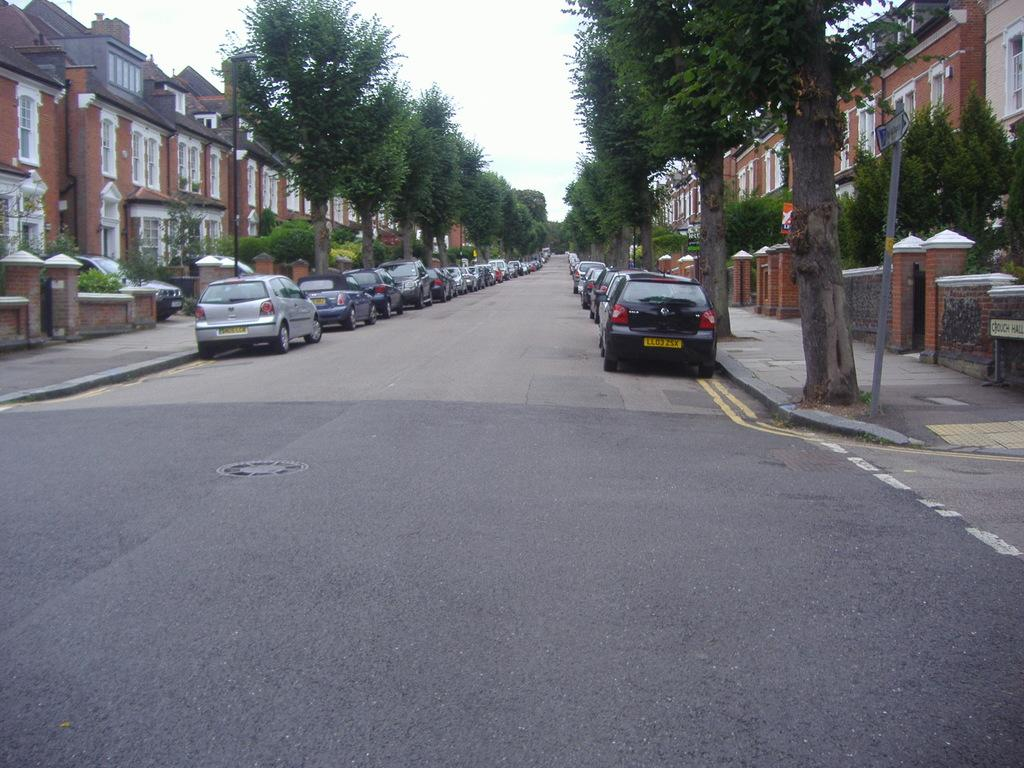What type of natural elements can be seen in the image? There are trees in the image. What type of man-made structures are visible in the image? There are buildings in the image. What are the tall, thin objects in the image? There are poles in the image. What type of vehicles can be seen in the image? There are cars in the image. How would you describe the setting of the image? The image appears to be a street view. Is there a bridge visible in the image? No, there is no bridge present in the image. Can you see a channel of water in the image? No, there is no channel of water visible in the image. 